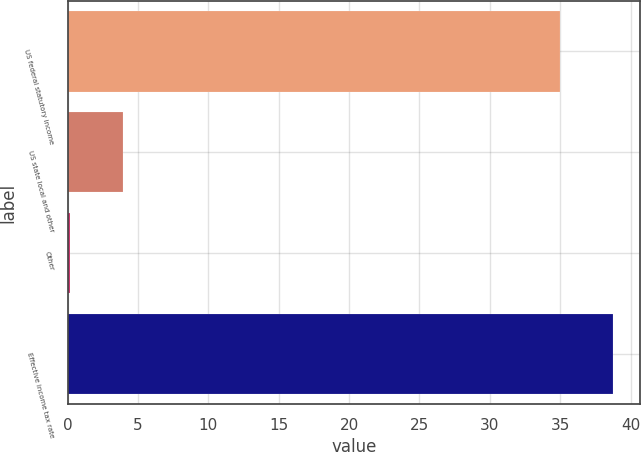Convert chart. <chart><loc_0><loc_0><loc_500><loc_500><bar_chart><fcel>US federal statutory income<fcel>US state local and other<fcel>Other<fcel>Effective income tax rate<nl><fcel>35<fcel>3.92<fcel>0.2<fcel>38.72<nl></chart> 